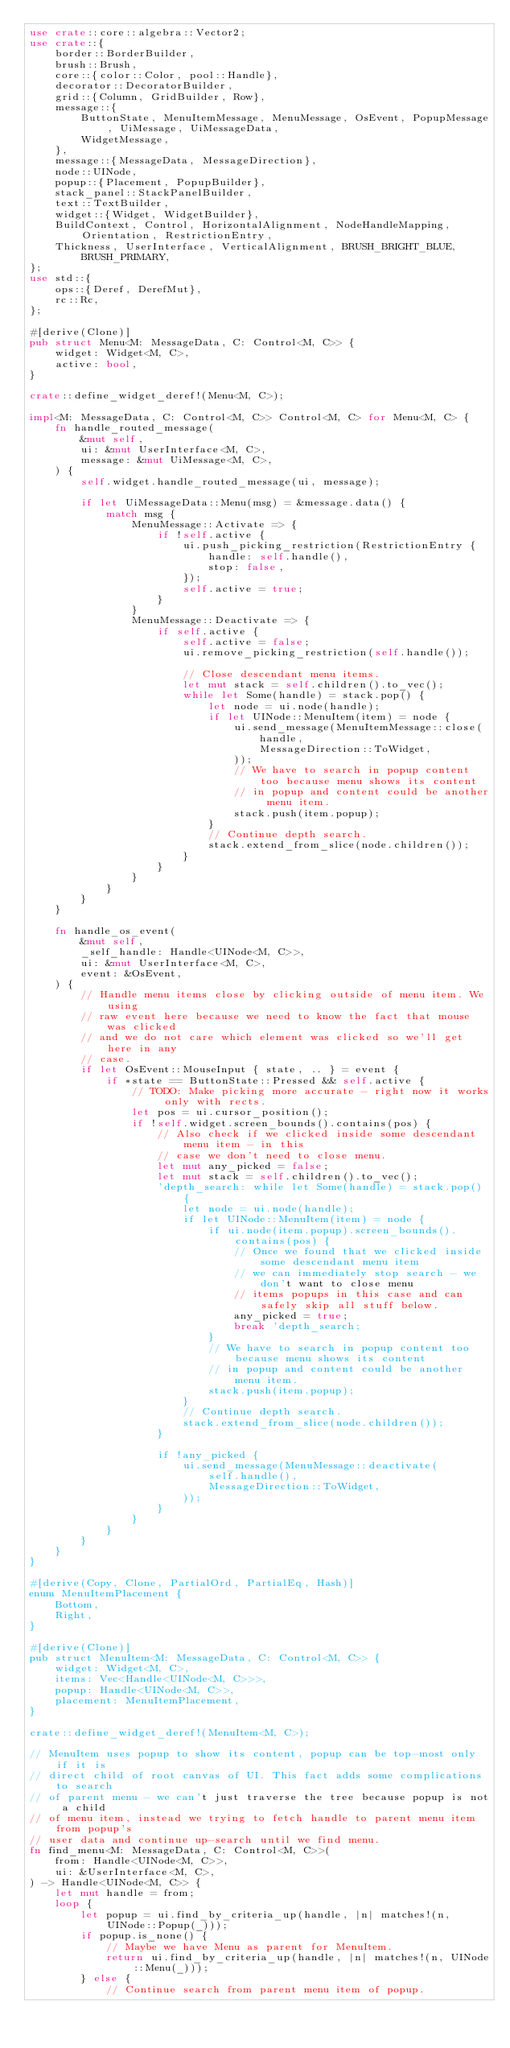<code> <loc_0><loc_0><loc_500><loc_500><_Rust_>use crate::core::algebra::Vector2;
use crate::{
    border::BorderBuilder,
    brush::Brush,
    core::{color::Color, pool::Handle},
    decorator::DecoratorBuilder,
    grid::{Column, GridBuilder, Row},
    message::{
        ButtonState, MenuItemMessage, MenuMessage, OsEvent, PopupMessage, UiMessage, UiMessageData,
        WidgetMessage,
    },
    message::{MessageData, MessageDirection},
    node::UINode,
    popup::{Placement, PopupBuilder},
    stack_panel::StackPanelBuilder,
    text::TextBuilder,
    widget::{Widget, WidgetBuilder},
    BuildContext, Control, HorizontalAlignment, NodeHandleMapping, Orientation, RestrictionEntry,
    Thickness, UserInterface, VerticalAlignment, BRUSH_BRIGHT_BLUE, BRUSH_PRIMARY,
};
use std::{
    ops::{Deref, DerefMut},
    rc::Rc,
};

#[derive(Clone)]
pub struct Menu<M: MessageData, C: Control<M, C>> {
    widget: Widget<M, C>,
    active: bool,
}

crate::define_widget_deref!(Menu<M, C>);

impl<M: MessageData, C: Control<M, C>> Control<M, C> for Menu<M, C> {
    fn handle_routed_message(
        &mut self,
        ui: &mut UserInterface<M, C>,
        message: &mut UiMessage<M, C>,
    ) {
        self.widget.handle_routed_message(ui, message);

        if let UiMessageData::Menu(msg) = &message.data() {
            match msg {
                MenuMessage::Activate => {
                    if !self.active {
                        ui.push_picking_restriction(RestrictionEntry {
                            handle: self.handle(),
                            stop: false,
                        });
                        self.active = true;
                    }
                }
                MenuMessage::Deactivate => {
                    if self.active {
                        self.active = false;
                        ui.remove_picking_restriction(self.handle());

                        // Close descendant menu items.
                        let mut stack = self.children().to_vec();
                        while let Some(handle) = stack.pop() {
                            let node = ui.node(handle);
                            if let UINode::MenuItem(item) = node {
                                ui.send_message(MenuItemMessage::close(
                                    handle,
                                    MessageDirection::ToWidget,
                                ));
                                // We have to search in popup content too because menu shows its content
                                // in popup and content could be another menu item.
                                stack.push(item.popup);
                            }
                            // Continue depth search.
                            stack.extend_from_slice(node.children());
                        }
                    }
                }
            }
        }
    }

    fn handle_os_event(
        &mut self,
        _self_handle: Handle<UINode<M, C>>,
        ui: &mut UserInterface<M, C>,
        event: &OsEvent,
    ) {
        // Handle menu items close by clicking outside of menu item. We using
        // raw event here because we need to know the fact that mouse was clicked
        // and we do not care which element was clicked so we'll get here in any
        // case.
        if let OsEvent::MouseInput { state, .. } = event {
            if *state == ButtonState::Pressed && self.active {
                // TODO: Make picking more accurate - right now it works only with rects.
                let pos = ui.cursor_position();
                if !self.widget.screen_bounds().contains(pos) {
                    // Also check if we clicked inside some descendant menu item - in this
                    // case we don't need to close menu.
                    let mut any_picked = false;
                    let mut stack = self.children().to_vec();
                    'depth_search: while let Some(handle) = stack.pop() {
                        let node = ui.node(handle);
                        if let UINode::MenuItem(item) = node {
                            if ui.node(item.popup).screen_bounds().contains(pos) {
                                // Once we found that we clicked inside some descendant menu item
                                // we can immediately stop search - we don't want to close menu
                                // items popups in this case and can safely skip all stuff below.
                                any_picked = true;
                                break 'depth_search;
                            }
                            // We have to search in popup content too because menu shows its content
                            // in popup and content could be another menu item.
                            stack.push(item.popup);
                        }
                        // Continue depth search.
                        stack.extend_from_slice(node.children());
                    }

                    if !any_picked {
                        ui.send_message(MenuMessage::deactivate(
                            self.handle(),
                            MessageDirection::ToWidget,
                        ));
                    }
                }
            }
        }
    }
}

#[derive(Copy, Clone, PartialOrd, PartialEq, Hash)]
enum MenuItemPlacement {
    Bottom,
    Right,
}

#[derive(Clone)]
pub struct MenuItem<M: MessageData, C: Control<M, C>> {
    widget: Widget<M, C>,
    items: Vec<Handle<UINode<M, C>>>,
    popup: Handle<UINode<M, C>>,
    placement: MenuItemPlacement,
}

crate::define_widget_deref!(MenuItem<M, C>);

// MenuItem uses popup to show its content, popup can be top-most only if it is
// direct child of root canvas of UI. This fact adds some complications to search
// of parent menu - we can't just traverse the tree because popup is not a child
// of menu item, instead we trying to fetch handle to parent menu item from popup's
// user data and continue up-search until we find menu.
fn find_menu<M: MessageData, C: Control<M, C>>(
    from: Handle<UINode<M, C>>,
    ui: &UserInterface<M, C>,
) -> Handle<UINode<M, C>> {
    let mut handle = from;
    loop {
        let popup = ui.find_by_criteria_up(handle, |n| matches!(n, UINode::Popup(_)));
        if popup.is_none() {
            // Maybe we have Menu as parent for MenuItem.
            return ui.find_by_criteria_up(handle, |n| matches!(n, UINode::Menu(_)));
        } else {
            // Continue search from parent menu item of popup.</code> 